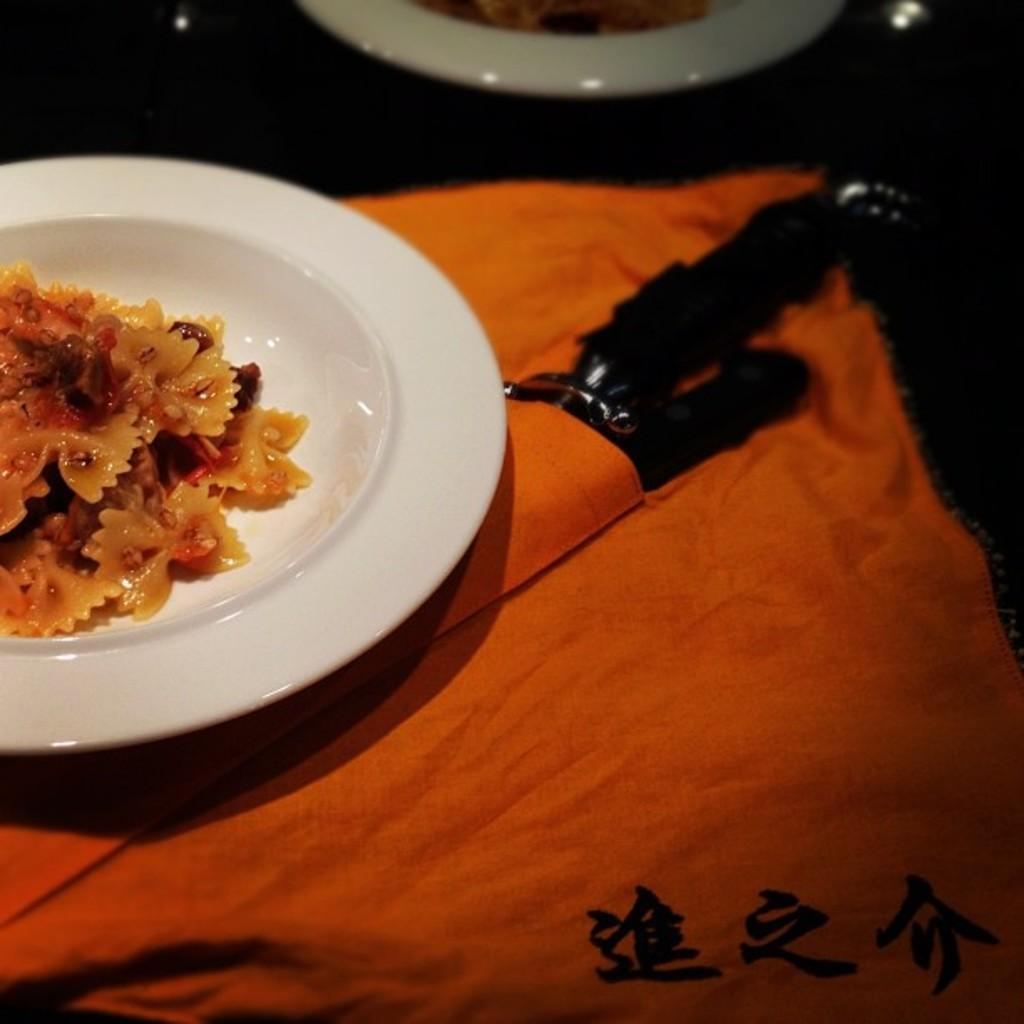What is the main food item visible in the image? There is a food item in a plate in the image. What else can be seen on the cloth in the image? There is an object on the cloth in the image. What is the item located on the platform at the top of the image? There is an item in a plate on a platform at the top of the image. What type of coast can be seen in the image? There is no coast visible in the image. How far can the canvas stretch in the image? There is no canvas present in the image. 